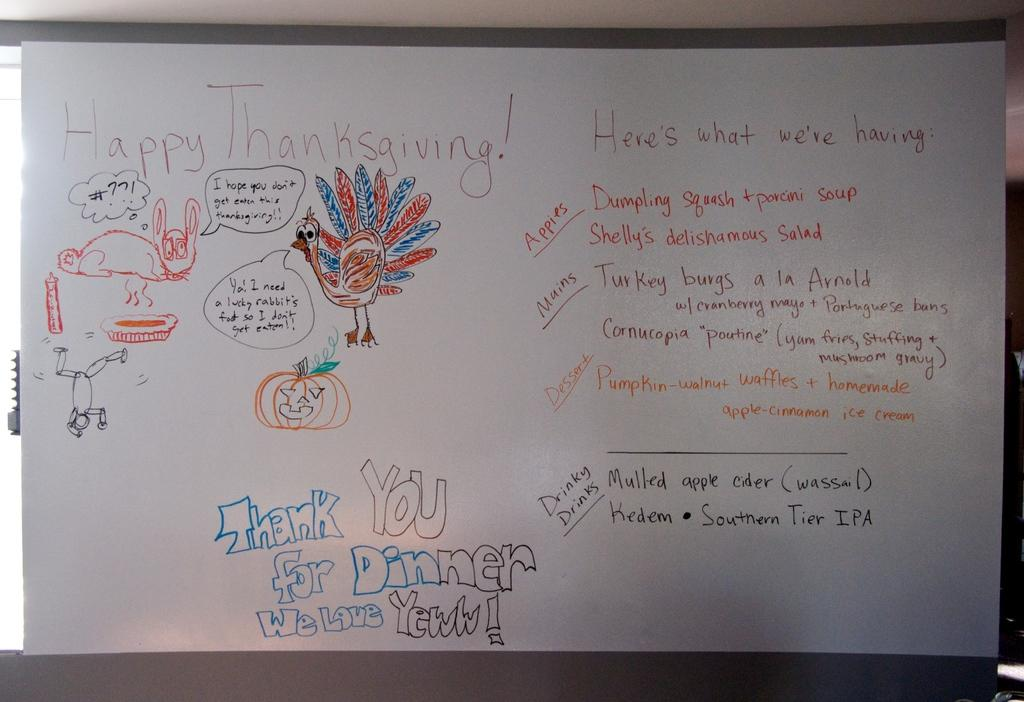Provide a one-sentence caption for the provided image. Happy Thanksgiving sign on a markerboard that says Happy Thanksgiving! Thank you for Dinner Welcome Yeww!. 